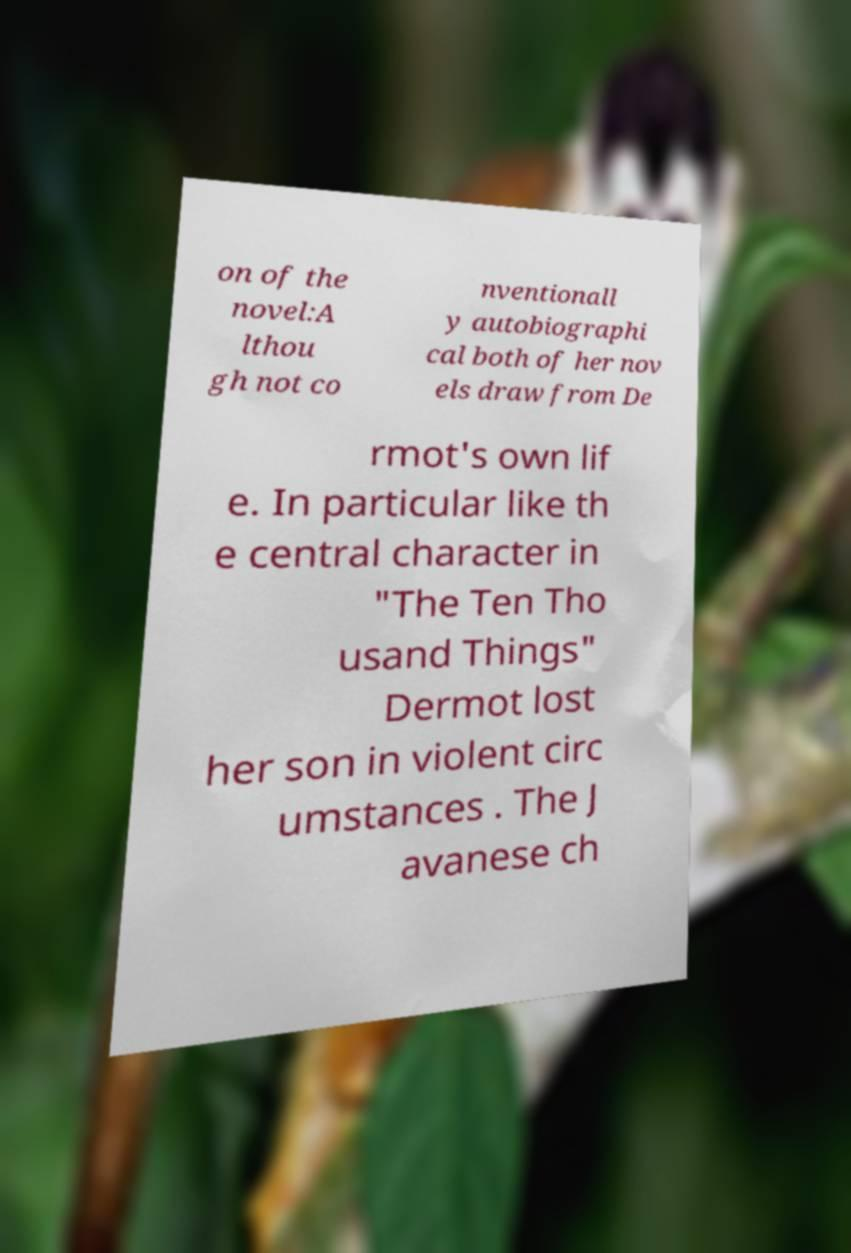Could you extract and type out the text from this image? on of the novel:A lthou gh not co nventionall y autobiographi cal both of her nov els draw from De rmot's own lif e. In particular like th e central character in "The Ten Tho usand Things" Dermot lost her son in violent circ umstances . The J avanese ch 